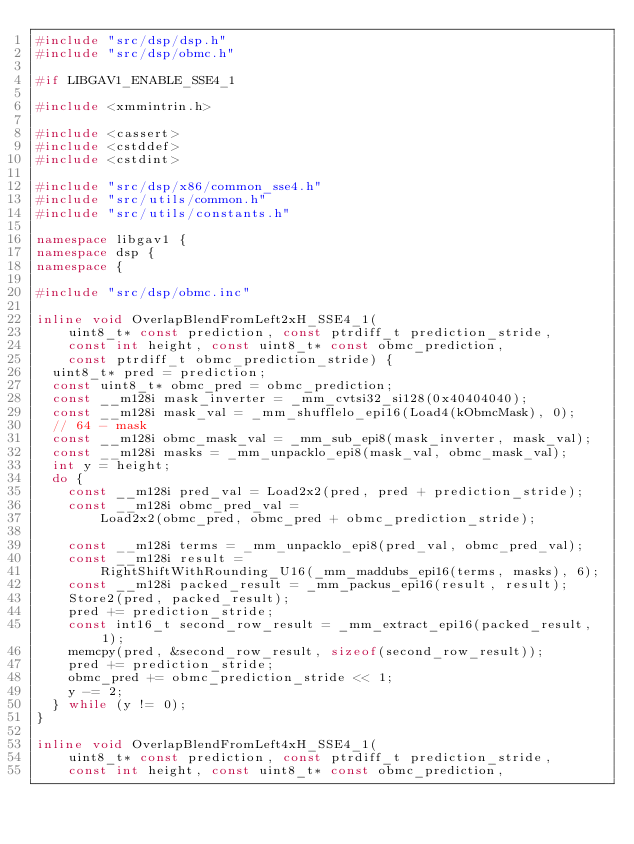Convert code to text. <code><loc_0><loc_0><loc_500><loc_500><_C++_>#include "src/dsp/dsp.h"
#include "src/dsp/obmc.h"

#if LIBGAV1_ENABLE_SSE4_1

#include <xmmintrin.h>

#include <cassert>
#include <cstddef>
#include <cstdint>

#include "src/dsp/x86/common_sse4.h"
#include "src/utils/common.h"
#include "src/utils/constants.h"

namespace libgav1 {
namespace dsp {
namespace {

#include "src/dsp/obmc.inc"

inline void OverlapBlendFromLeft2xH_SSE4_1(
    uint8_t* const prediction, const ptrdiff_t prediction_stride,
    const int height, const uint8_t* const obmc_prediction,
    const ptrdiff_t obmc_prediction_stride) {
  uint8_t* pred = prediction;
  const uint8_t* obmc_pred = obmc_prediction;
  const __m128i mask_inverter = _mm_cvtsi32_si128(0x40404040);
  const __m128i mask_val = _mm_shufflelo_epi16(Load4(kObmcMask), 0);
  // 64 - mask
  const __m128i obmc_mask_val = _mm_sub_epi8(mask_inverter, mask_val);
  const __m128i masks = _mm_unpacklo_epi8(mask_val, obmc_mask_val);
  int y = height;
  do {
    const __m128i pred_val = Load2x2(pred, pred + prediction_stride);
    const __m128i obmc_pred_val =
        Load2x2(obmc_pred, obmc_pred + obmc_prediction_stride);

    const __m128i terms = _mm_unpacklo_epi8(pred_val, obmc_pred_val);
    const __m128i result =
        RightShiftWithRounding_U16(_mm_maddubs_epi16(terms, masks), 6);
    const __m128i packed_result = _mm_packus_epi16(result, result);
    Store2(pred, packed_result);
    pred += prediction_stride;
    const int16_t second_row_result = _mm_extract_epi16(packed_result, 1);
    memcpy(pred, &second_row_result, sizeof(second_row_result));
    pred += prediction_stride;
    obmc_pred += obmc_prediction_stride << 1;
    y -= 2;
  } while (y != 0);
}

inline void OverlapBlendFromLeft4xH_SSE4_1(
    uint8_t* const prediction, const ptrdiff_t prediction_stride,
    const int height, const uint8_t* const obmc_prediction,</code> 